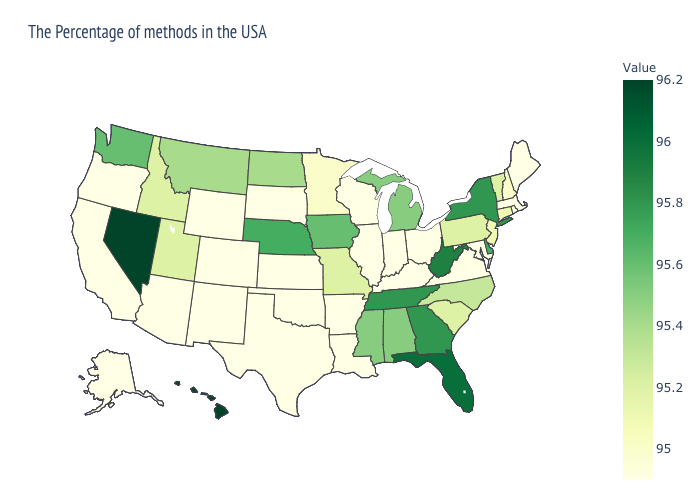Does Massachusetts have the lowest value in the Northeast?
Keep it brief. Yes. Does Florida have the highest value in the South?
Short answer required. Yes. Does Arkansas have the highest value in the USA?
Keep it brief. No. Among the states that border Oregon , which have the lowest value?
Short answer required. California. Which states have the highest value in the USA?
Write a very short answer. Nevada, Hawaii. Which states have the lowest value in the Northeast?
Short answer required. Maine, Massachusetts, Rhode Island. 